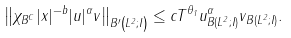Convert formula to latex. <formula><loc_0><loc_0><loc_500><loc_500>\left \| \chi _ { B ^ { C } } | x | ^ { - b } | u | ^ { \alpha } v \right \| _ { B ^ { \prime } \left ( L ^ { 2 } ; I \right ) } \leq c T ^ { \theta _ { 1 } } \| u \| ^ { \alpha } _ { B ( L ^ { 2 } ; I ) } \| v \| _ { B ( L ^ { 2 } ; I ) } .</formula> 